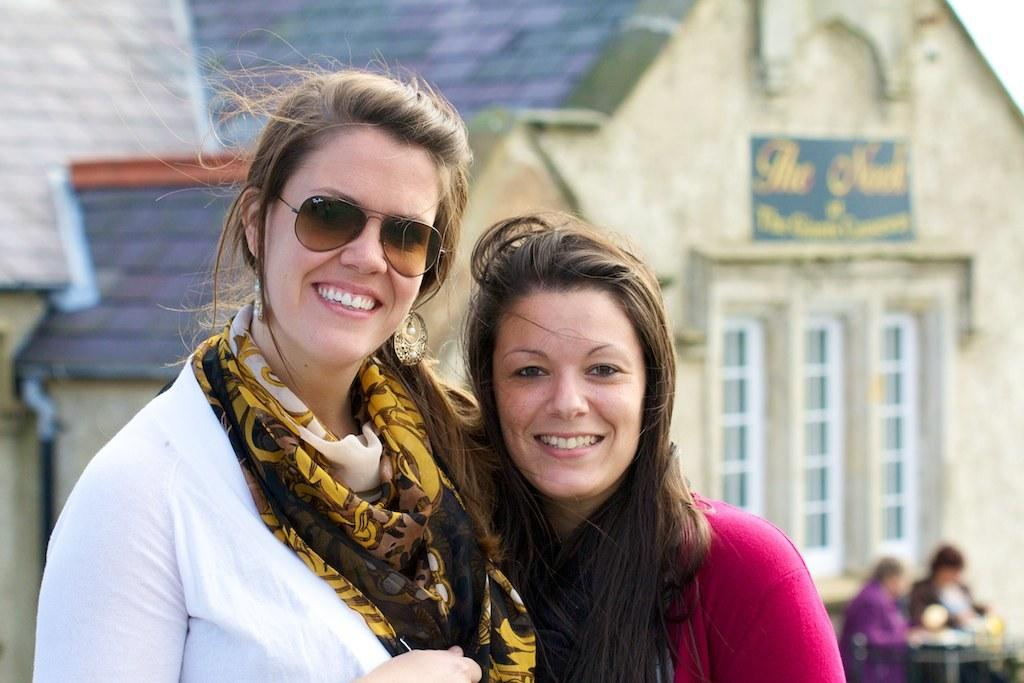How many women are present in the image? There are 2 women in the image. What are the women doing in the image? The women are standing and smiling. What can be seen in the background of the image? There is a building and other people in the background of the image. What type of hat is the straw wearing in the image? There is no straw or hat present in the image. How does the sponge contribute to the scene in the image? There is no sponge present in the image. 